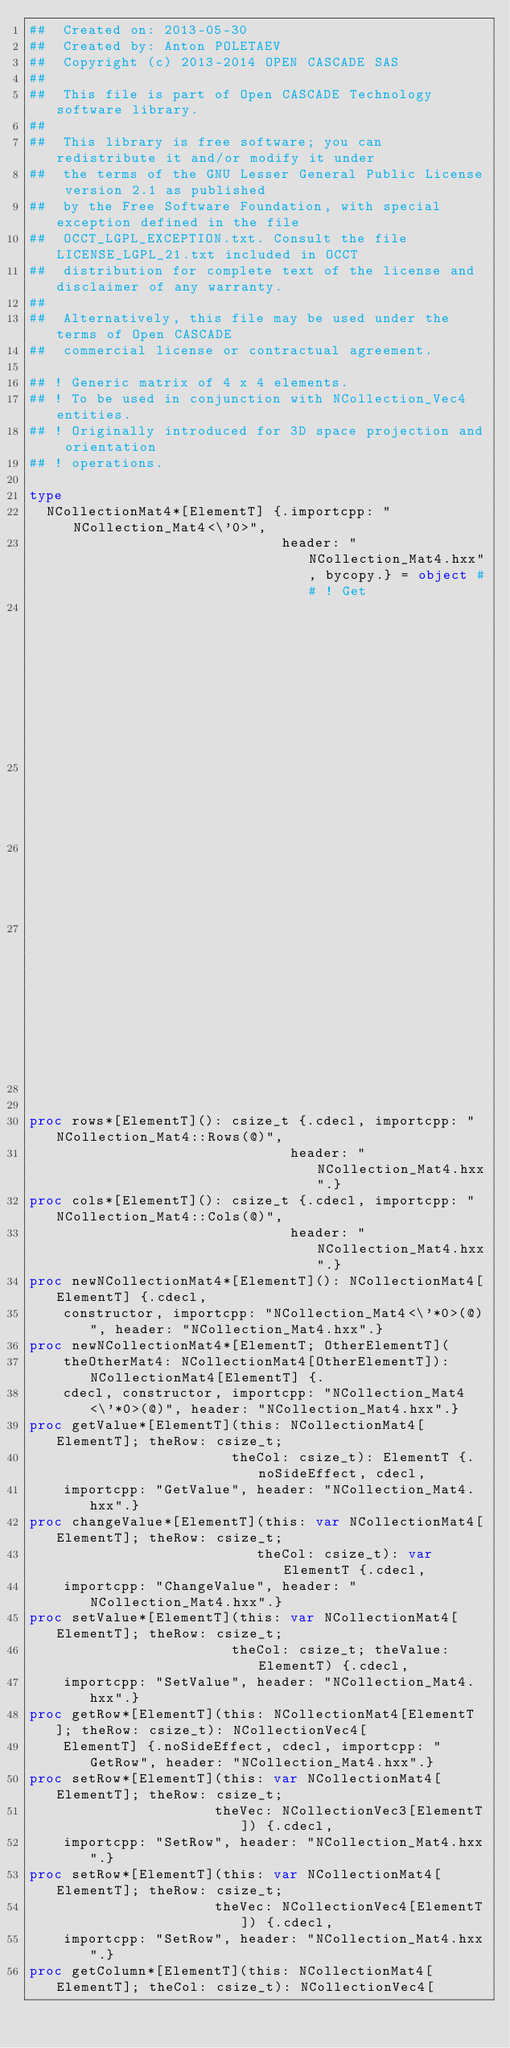<code> <loc_0><loc_0><loc_500><loc_500><_Nim_>##  Created on: 2013-05-30
##  Created by: Anton POLETAEV
##  Copyright (c) 2013-2014 OPEN CASCADE SAS
##
##  This file is part of Open CASCADE Technology software library.
##
##  This library is free software; you can redistribute it and/or modify it under
##  the terms of the GNU Lesser General Public License version 2.1 as published
##  by the Free Software Foundation, with special exception defined in the file
##  OCCT_LGPL_EXCEPTION.txt. Consult the file LICENSE_LGPL_21.txt included in OCCT
##  distribution for complete text of the license and disclaimer of any warranty.
##
##  Alternatively, this file may be used under the terms of Open CASCADE
##  commercial license or contractual agreement.

## ! Generic matrix of 4 x 4 elements.
## ! To be used in conjunction with NCollection_Vec4 entities.
## ! Originally introduced for 3D space projection and orientation
## ! operations.

type
  NCollectionMat4*[ElementT] {.importcpp: "NCollection_Mat4<\'0>",
                              header: "NCollection_Mat4.hxx", bycopy.} = object ## ! Get
                                                                           ## number of rows.
                                                                           ## !
                                                                           ## @return
                                                                           ## number of rows.


proc rows*[ElementT](): csize_t {.cdecl, importcpp: "NCollection_Mat4::Rows(@)",
                               header: "NCollection_Mat4.hxx".}
proc cols*[ElementT](): csize_t {.cdecl, importcpp: "NCollection_Mat4::Cols(@)",
                               header: "NCollection_Mat4.hxx".}
proc newNCollectionMat4*[ElementT](): NCollectionMat4[ElementT] {.cdecl,
    constructor, importcpp: "NCollection_Mat4<\'*0>(@)", header: "NCollection_Mat4.hxx".}
proc newNCollectionMat4*[ElementT; OtherElementT](
    theOtherMat4: NCollectionMat4[OtherElementT]): NCollectionMat4[ElementT] {.
    cdecl, constructor, importcpp: "NCollection_Mat4<\'*0>(@)", header: "NCollection_Mat4.hxx".}
proc getValue*[ElementT](this: NCollectionMat4[ElementT]; theRow: csize_t;
                        theCol: csize_t): ElementT {.noSideEffect, cdecl,
    importcpp: "GetValue", header: "NCollection_Mat4.hxx".}
proc changeValue*[ElementT](this: var NCollectionMat4[ElementT]; theRow: csize_t;
                           theCol: csize_t): var ElementT {.cdecl,
    importcpp: "ChangeValue", header: "NCollection_Mat4.hxx".}
proc setValue*[ElementT](this: var NCollectionMat4[ElementT]; theRow: csize_t;
                        theCol: csize_t; theValue: ElementT) {.cdecl,
    importcpp: "SetValue", header: "NCollection_Mat4.hxx".}
proc getRow*[ElementT](this: NCollectionMat4[ElementT]; theRow: csize_t): NCollectionVec4[
    ElementT] {.noSideEffect, cdecl, importcpp: "GetRow", header: "NCollection_Mat4.hxx".}
proc setRow*[ElementT](this: var NCollectionMat4[ElementT]; theRow: csize_t;
                      theVec: NCollectionVec3[ElementT]) {.cdecl,
    importcpp: "SetRow", header: "NCollection_Mat4.hxx".}
proc setRow*[ElementT](this: var NCollectionMat4[ElementT]; theRow: csize_t;
                      theVec: NCollectionVec4[ElementT]) {.cdecl,
    importcpp: "SetRow", header: "NCollection_Mat4.hxx".}
proc getColumn*[ElementT](this: NCollectionMat4[ElementT]; theCol: csize_t): NCollectionVec4[</code> 